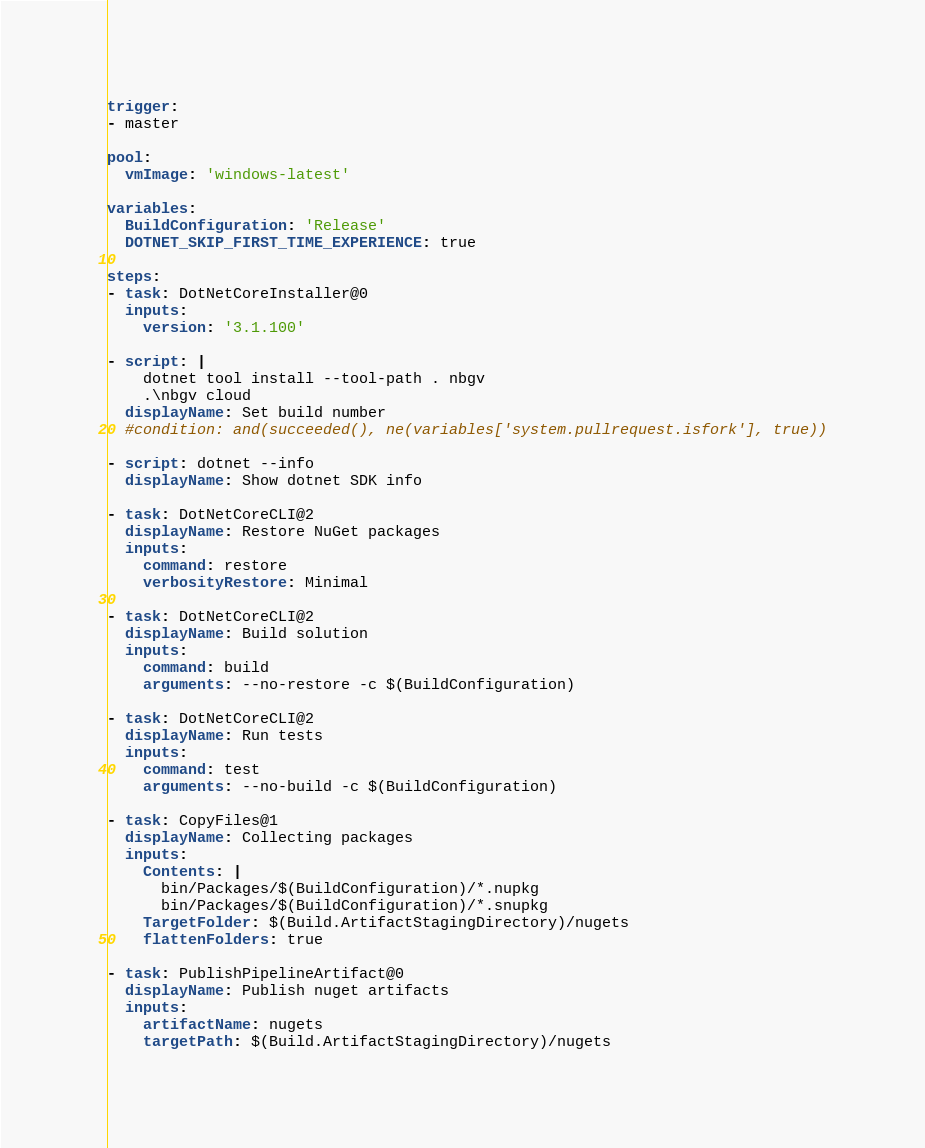Convert code to text. <code><loc_0><loc_0><loc_500><loc_500><_YAML_>
trigger:
- master

pool:
  vmImage: 'windows-latest'

variables:
  BuildConfiguration: 'Release'
  DOTNET_SKIP_FIRST_TIME_EXPERIENCE: true

steps:
- task: DotNetCoreInstaller@0
  inputs:
    version: '3.1.100'

- script: |
    dotnet tool install --tool-path . nbgv
    .\nbgv cloud
  displayName: Set build number
  #condition: and(succeeded(), ne(variables['system.pullrequest.isfork'], true))

- script: dotnet --info
  displayName: Show dotnet SDK info

- task: DotNetCoreCLI@2
  displayName: Restore NuGet packages
  inputs:
    command: restore
    verbosityRestore: Minimal

- task: DotNetCoreCLI@2
  displayName: Build solution
  inputs:
    command: build
    arguments: --no-restore -c $(BuildConfiguration)

- task: DotNetCoreCLI@2
  displayName: Run tests
  inputs:
    command: test
    arguments: --no-build -c $(BuildConfiguration)

- task: CopyFiles@1
  displayName: Collecting packages
  inputs:
    Contents: |
      bin/Packages/$(BuildConfiguration)/*.nupkg
      bin/Packages/$(BuildConfiguration)/*.snupkg
    TargetFolder: $(Build.ArtifactStagingDirectory)/nugets
    flattenFolders: true

- task: PublishPipelineArtifact@0
  displayName: Publish nuget artifacts
  inputs:
    artifactName: nugets
    targetPath: $(Build.ArtifactStagingDirectory)/nugets
</code> 